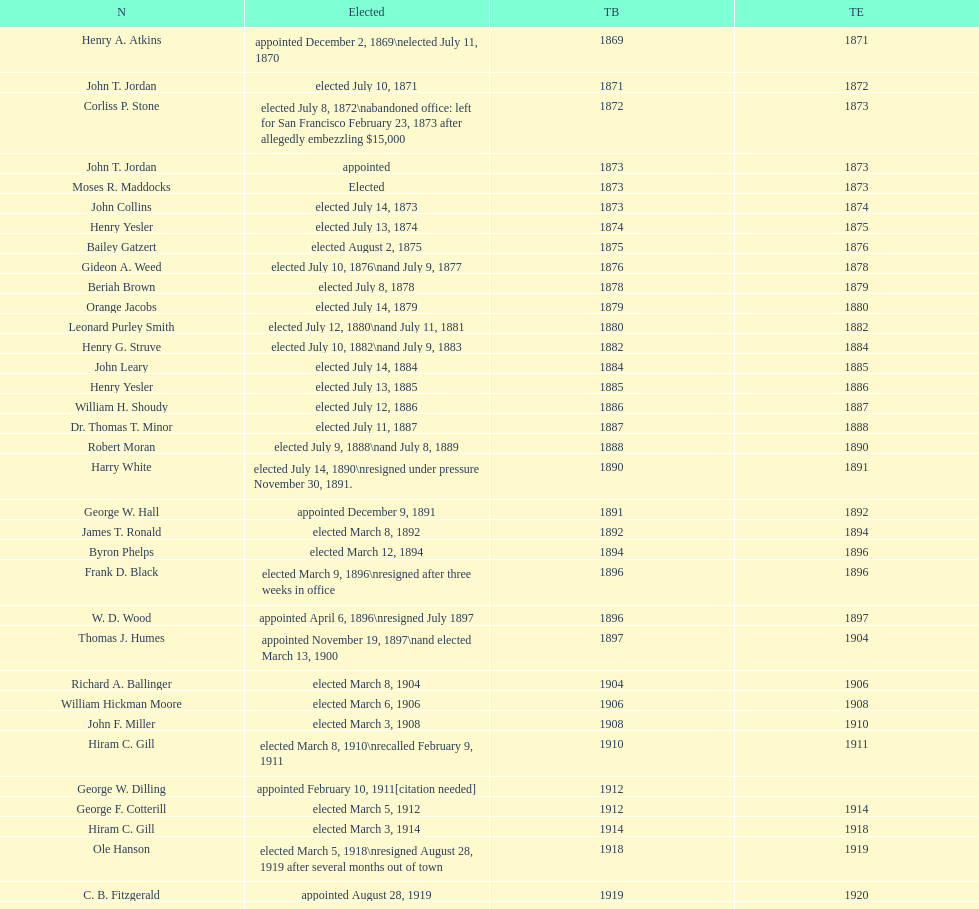Who was mayor of seattle, washington before being appointed to department of transportation during the nixon administration? James d'Orma Braman. 